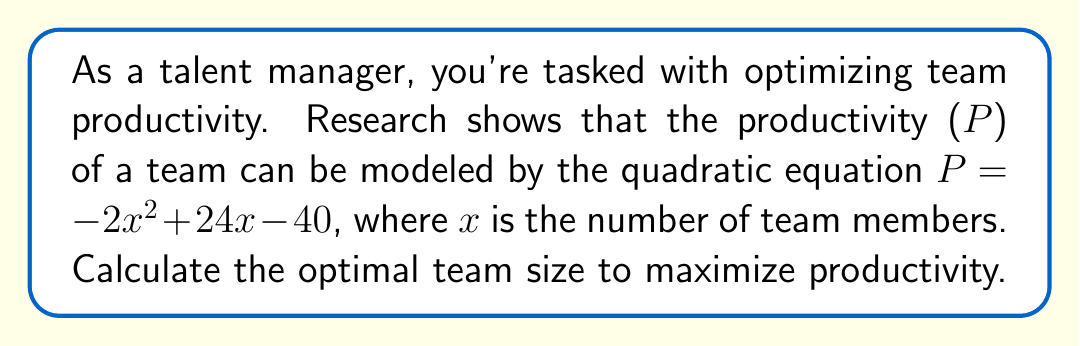Show me your answer to this math problem. To find the optimal team size, we need to find the maximum value of the quadratic function. This occurs at the vertex of the parabola.

Step 1: Identify the quadratic equation
$P = -2x^2 + 24x - 40$

Step 2: Use the vertex formula for a quadratic equation in the form $ax^2 + bx + c$
The x-coordinate of the vertex is given by $x = -\frac{b}{2a}$

Step 3: Identify $a$ and $b$
$a = -2$
$b = 24$

Step 4: Calculate the x-coordinate of the vertex
$x = -\frac{24}{2(-2)} = -\frac{24}{-4} = 6$

Step 5: Verify that this is a maximum (not a minimum)
Since $a$ is negative ($-2$), the parabola opens downward, confirming that the vertex is a maximum.

Therefore, the optimal team size is 6 members.
Answer: 6 team members 